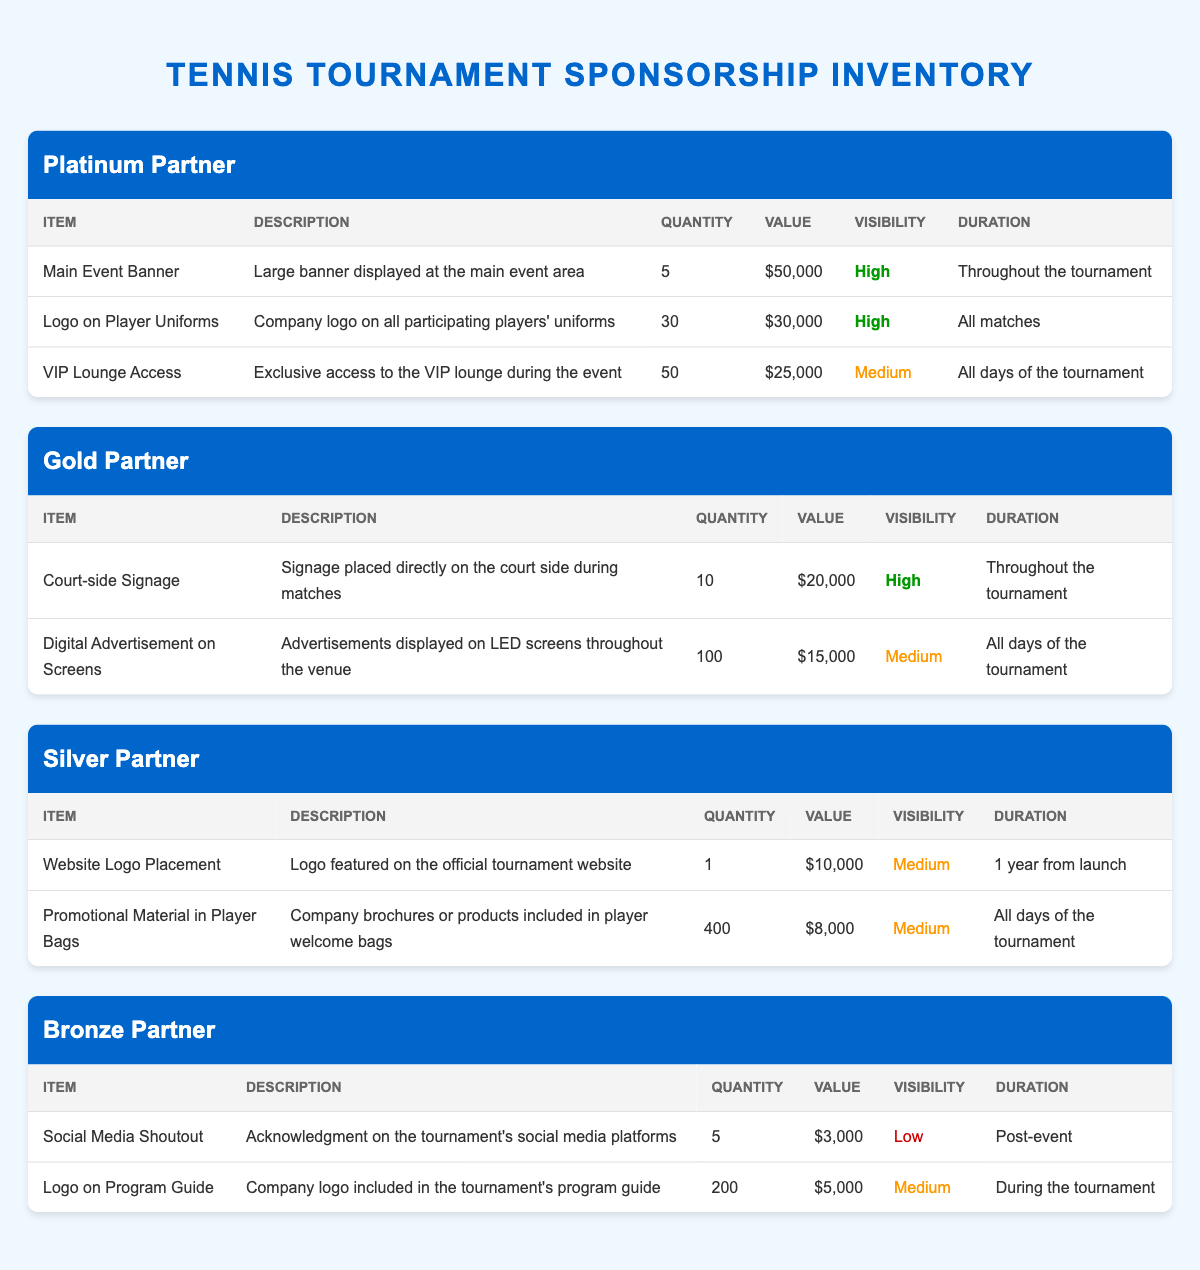What is the total quantity of "Logo on Player Uniforms" available in the Platinum Partner package? The Platinum Partner package offers "Logo on Player Uniforms" with a quantity of 30. We can directly read this information from the table without any calculation.
Answer: 30 What is the value of "Digital Advertisement on Screens" offered in the Gold Partner package? The Gold Partner package lists "Digital Advertisement on Screens" with a value of 15,000. This value can be found directly in the corresponding row of the table.
Answer: 15000 Which sponsorship package offers access to the VIP lounge? The VIP Lounge Access is an inventory item under the Platinum Partner package. The information can be directly retrieved from the table.
Answer: Platinum Partner What is the combined value of all items in the Silver Partner package? To find the total value for the Silver Partner package, we sum the values of the two items: Website Logo Placement ($10,000) + Promotional Material in Player Bags ($8,000) = $18,000. This calculation involves adding the values listed in the table.
Answer: 18000 Does the Bronze Partner package include a Social Media Shoutout? Yes, the Bronze Partner package has "Social Media Shoutout" as one of its inventory items. This is explicitly mentioned in the table.
Answer: Yes What is the average visibility rating value (High=3, Medium=2, Low=1) of the inventory items in the Gold Partner package? The Gold Partner package contains two items: Court-side Signage (High=3) and Digital Advertisement on Screens (Medium=2). We convert the visibility ratings to numerical values: (3 + 2) / 2 = 2.5. This requires calculating the average based on their respective visibility ratings.
Answer: 2.5 Which inventory item has the lowest visibility in the table? The item "Social Media Shoutout" in the Bronze Partner package has the visibility rating of Low. By examining the visibility column in the table, we can identify it.
Answer: Social Media Shoutout How many total inventory items are listed across all sponsorship packages? To find the total, we add all the quantities from each package: 3 (Platinum) + 2 (Gold) + 2 (Silver) + 2 (Bronze) = 9 items in total. This involves counting the inventory items across the different packages.
Answer: 9 What is the total quantity of promotional materials in the Silver Partner package? The Silver Partner package offers 400 units of "Promotional Material in Player Bags." This data can be directly retrieved from the table entries for that package.
Answer: 400 